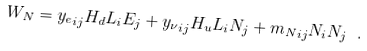<formula> <loc_0><loc_0><loc_500><loc_500>W _ { N } = { y _ { e } } _ { i j } H _ { d } L _ { i } E _ { j } + { y _ { \nu } } _ { i j } H _ { u } L _ { i } N _ { j } + { m _ { N } } _ { i j } N _ { i } N _ { j } \ .</formula> 